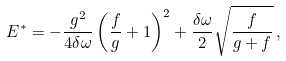Convert formula to latex. <formula><loc_0><loc_0><loc_500><loc_500>E ^ { * } = - \frac { g ^ { 2 } } { 4 \delta \omega } \left ( \frac { f } { g } + 1 \right ) ^ { 2 } + \frac { \delta \omega } { 2 } \sqrt { \frac { f } { g + f } } \, ,</formula> 